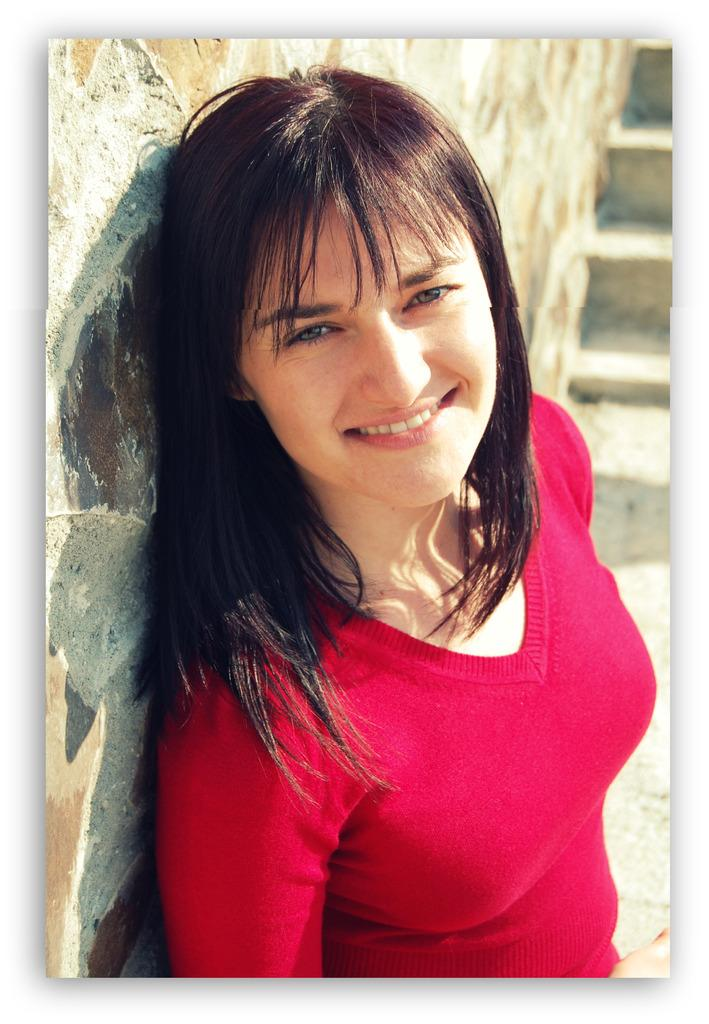Who is present in the image? There is a woman in the image. What is the woman doing in the image? The woman is standing with a smile on her face. What can be seen behind the woman? There is a wall behind the woman. Are there any architectural features in the image? Yes, there are stairs in the image. What type of kite is being flown during the protest in the image? There is no kite or protest present in the image; it features a woman standing with a smile on her face in front of a wall and stairs. 